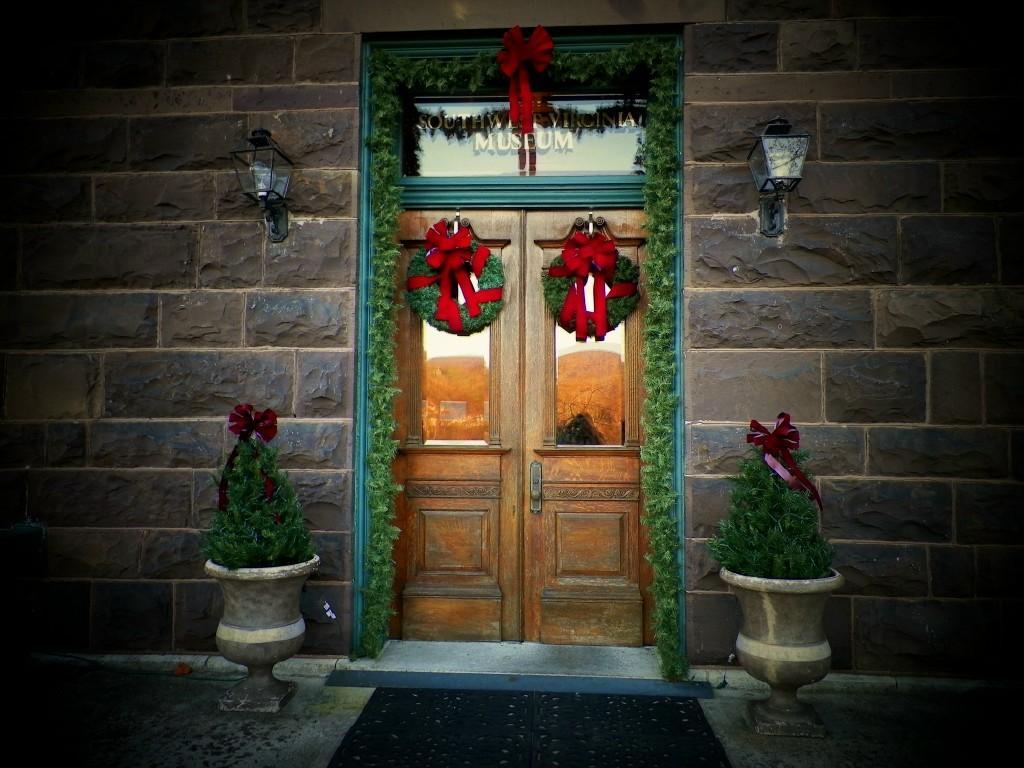How would you summarize this image in a sentence or two? In this image I can see the wall, brown colour doors, plants, ribbons and here I can see few green colour things. I can also see few lights on this wall. 